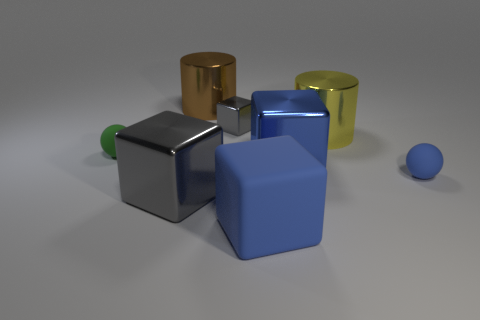How many large gray things have the same shape as the small gray shiny thing? 1 